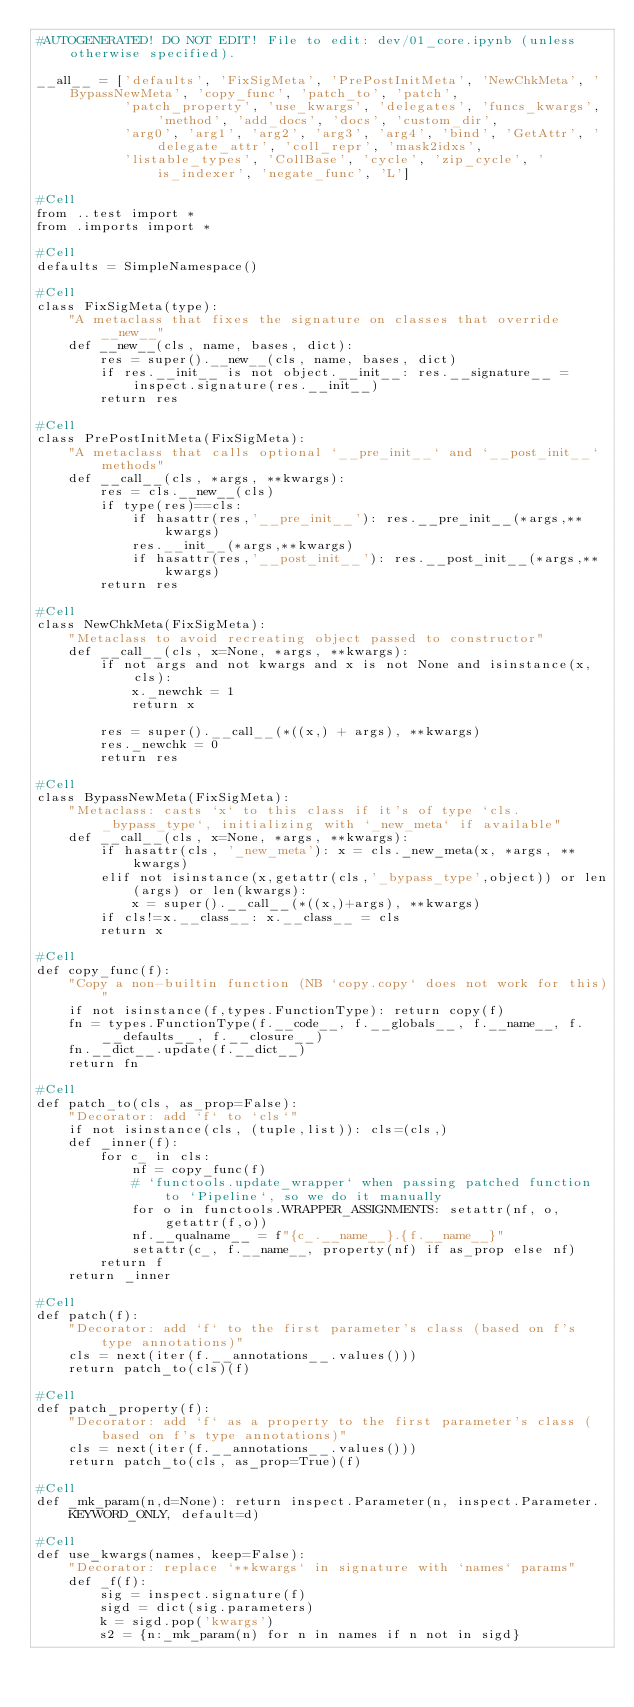Convert code to text. <code><loc_0><loc_0><loc_500><loc_500><_Python_>#AUTOGENERATED! DO NOT EDIT! File to edit: dev/01_core.ipynb (unless otherwise specified).

__all__ = ['defaults', 'FixSigMeta', 'PrePostInitMeta', 'NewChkMeta', 'BypassNewMeta', 'copy_func', 'patch_to', 'patch',
           'patch_property', 'use_kwargs', 'delegates', 'funcs_kwargs', 'method', 'add_docs', 'docs', 'custom_dir',
           'arg0', 'arg1', 'arg2', 'arg3', 'arg4', 'bind', 'GetAttr', 'delegate_attr', 'coll_repr', 'mask2idxs',
           'listable_types', 'CollBase', 'cycle', 'zip_cycle', 'is_indexer', 'negate_func', 'L']

#Cell
from ..test import *
from .imports import *

#Cell
defaults = SimpleNamespace()

#Cell
class FixSigMeta(type):
    "A metaclass that fixes the signature on classes that override __new__"
    def __new__(cls, name, bases, dict):
        res = super().__new__(cls, name, bases, dict)
        if res.__init__ is not object.__init__: res.__signature__ = inspect.signature(res.__init__)
        return res

#Cell
class PrePostInitMeta(FixSigMeta):
    "A metaclass that calls optional `__pre_init__` and `__post_init__` methods"
    def __call__(cls, *args, **kwargs):
        res = cls.__new__(cls)
        if type(res)==cls:
            if hasattr(res,'__pre_init__'): res.__pre_init__(*args,**kwargs)
            res.__init__(*args,**kwargs)
            if hasattr(res,'__post_init__'): res.__post_init__(*args,**kwargs)
        return res

#Cell
class NewChkMeta(FixSigMeta):
    "Metaclass to avoid recreating object passed to constructor"
    def __call__(cls, x=None, *args, **kwargs):
        if not args and not kwargs and x is not None and isinstance(x,cls):
            x._newchk = 1
            return x

        res = super().__call__(*((x,) + args), **kwargs)
        res._newchk = 0
        return res

#Cell
class BypassNewMeta(FixSigMeta):
    "Metaclass: casts `x` to this class if it's of type `cls._bypass_type`, initializing with `_new_meta` if available"
    def __call__(cls, x=None, *args, **kwargs):
        if hasattr(cls, '_new_meta'): x = cls._new_meta(x, *args, **kwargs)
        elif not isinstance(x,getattr(cls,'_bypass_type',object)) or len(args) or len(kwargs):
            x = super().__call__(*((x,)+args), **kwargs)
        if cls!=x.__class__: x.__class__ = cls
        return x

#Cell
def copy_func(f):
    "Copy a non-builtin function (NB `copy.copy` does not work for this)"
    if not isinstance(f,types.FunctionType): return copy(f)
    fn = types.FunctionType(f.__code__, f.__globals__, f.__name__, f.__defaults__, f.__closure__)
    fn.__dict__.update(f.__dict__)
    return fn

#Cell
def patch_to(cls, as_prop=False):
    "Decorator: add `f` to `cls`"
    if not isinstance(cls, (tuple,list)): cls=(cls,)
    def _inner(f):
        for c_ in cls:
            nf = copy_func(f)
            # `functools.update_wrapper` when passing patched function to `Pipeline`, so we do it manually
            for o in functools.WRAPPER_ASSIGNMENTS: setattr(nf, o, getattr(f,o))
            nf.__qualname__ = f"{c_.__name__}.{f.__name__}"
            setattr(c_, f.__name__, property(nf) if as_prop else nf)
        return f
    return _inner

#Cell
def patch(f):
    "Decorator: add `f` to the first parameter's class (based on f's type annotations)"
    cls = next(iter(f.__annotations__.values()))
    return patch_to(cls)(f)

#Cell
def patch_property(f):
    "Decorator: add `f` as a property to the first parameter's class (based on f's type annotations)"
    cls = next(iter(f.__annotations__.values()))
    return patch_to(cls, as_prop=True)(f)

#Cell
def _mk_param(n,d=None): return inspect.Parameter(n, inspect.Parameter.KEYWORD_ONLY, default=d)

#Cell
def use_kwargs(names, keep=False):
    "Decorator: replace `**kwargs` in signature with `names` params"
    def _f(f):
        sig = inspect.signature(f)
        sigd = dict(sig.parameters)
        k = sigd.pop('kwargs')
        s2 = {n:_mk_param(n) for n in names if n not in sigd}</code> 